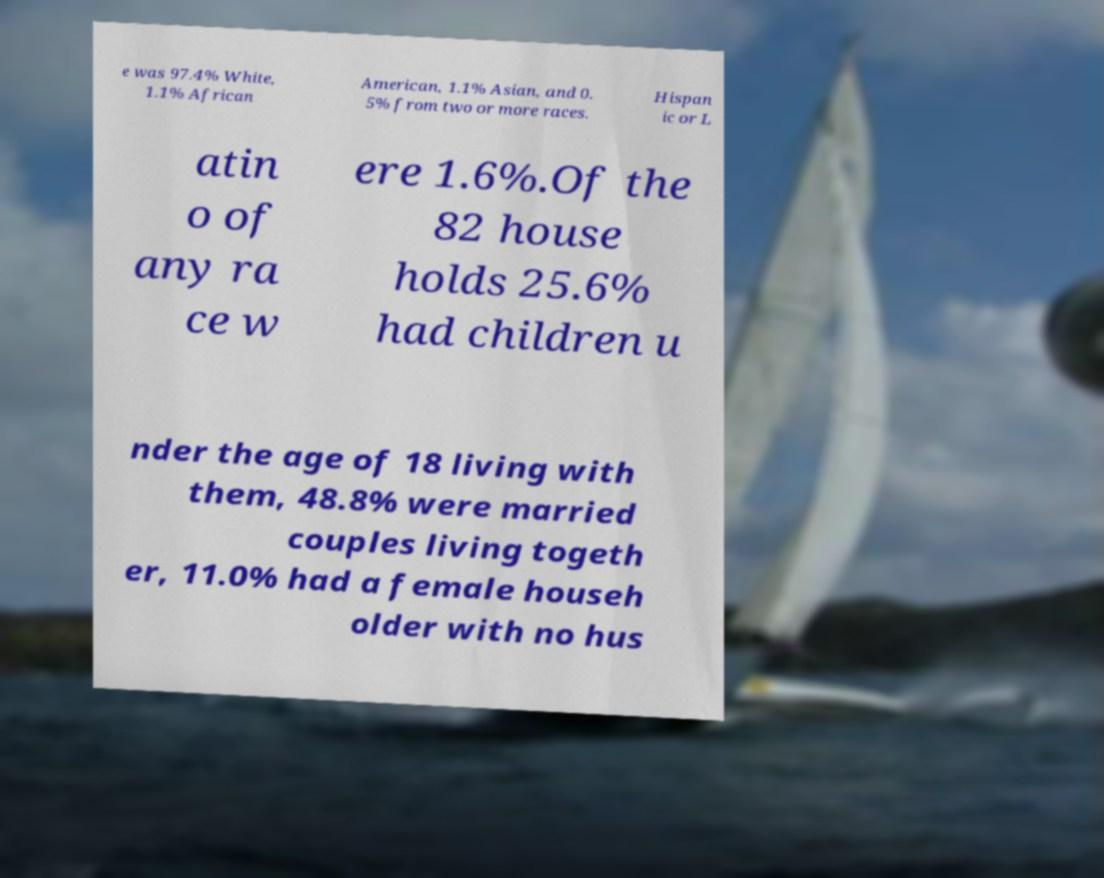What messages or text are displayed in this image? I need them in a readable, typed format. e was 97.4% White, 1.1% African American, 1.1% Asian, and 0. 5% from two or more races. Hispan ic or L atin o of any ra ce w ere 1.6%.Of the 82 house holds 25.6% had children u nder the age of 18 living with them, 48.8% were married couples living togeth er, 11.0% had a female househ older with no hus 